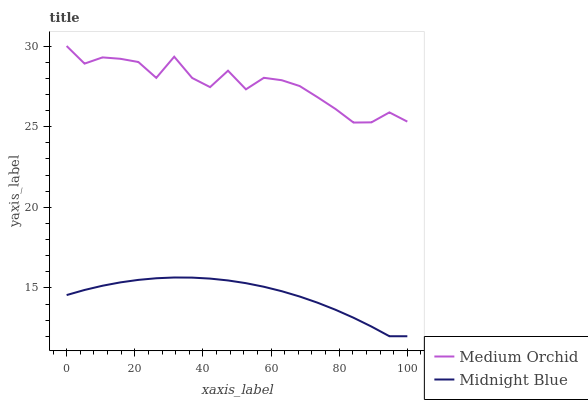Does Midnight Blue have the minimum area under the curve?
Answer yes or no. Yes. Does Medium Orchid have the maximum area under the curve?
Answer yes or no. Yes. Does Midnight Blue have the maximum area under the curve?
Answer yes or no. No. Is Midnight Blue the smoothest?
Answer yes or no. Yes. Is Medium Orchid the roughest?
Answer yes or no. Yes. Is Midnight Blue the roughest?
Answer yes or no. No. Does Medium Orchid have the highest value?
Answer yes or no. Yes. Does Midnight Blue have the highest value?
Answer yes or no. No. Is Midnight Blue less than Medium Orchid?
Answer yes or no. Yes. Is Medium Orchid greater than Midnight Blue?
Answer yes or no. Yes. Does Midnight Blue intersect Medium Orchid?
Answer yes or no. No. 